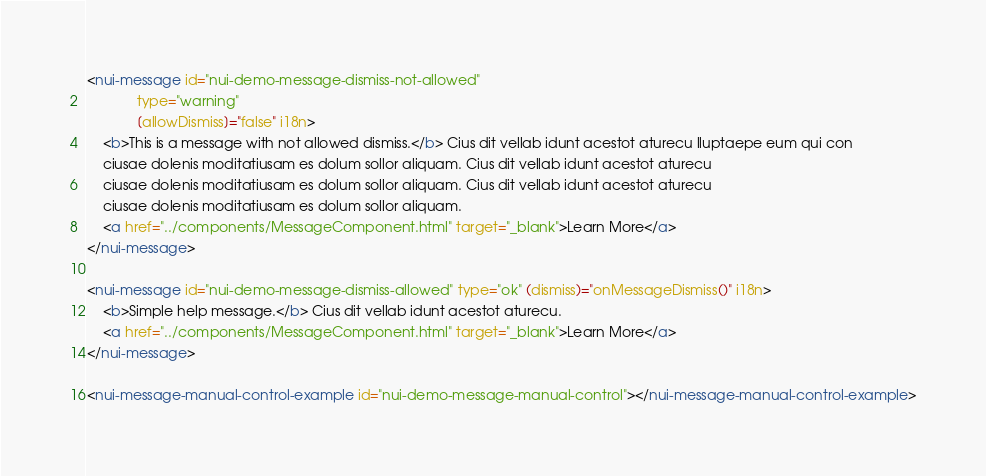Convert code to text. <code><loc_0><loc_0><loc_500><loc_500><_HTML_><nui-message id="nui-demo-message-dismiss-not-allowed"
             type="warning"
             [allowDismiss]="false" i18n>
    <b>This is a message with not allowed dismiss.</b> Cius dit vellab idunt acestot aturecu lluptaepe eum qui con
    ciusae dolenis moditatiusam es dolum sollor aliquam. Cius dit vellab idunt acestot aturecu
    ciusae dolenis moditatiusam es dolum sollor aliquam. Cius dit vellab idunt acestot aturecu
    ciusae dolenis moditatiusam es dolum sollor aliquam.
    <a href="../components/MessageComponent.html" target="_blank">Learn More</a>
</nui-message>

<nui-message id="nui-demo-message-dismiss-allowed" type="ok" (dismiss)="onMessageDismiss()" i18n>
    <b>Simple help message.</b> Cius dit vellab idunt acestot aturecu.
    <a href="../components/MessageComponent.html" target="_blank">Learn More</a>
</nui-message>

<nui-message-manual-control-example id="nui-demo-message-manual-control"></nui-message-manual-control-example>
</code> 